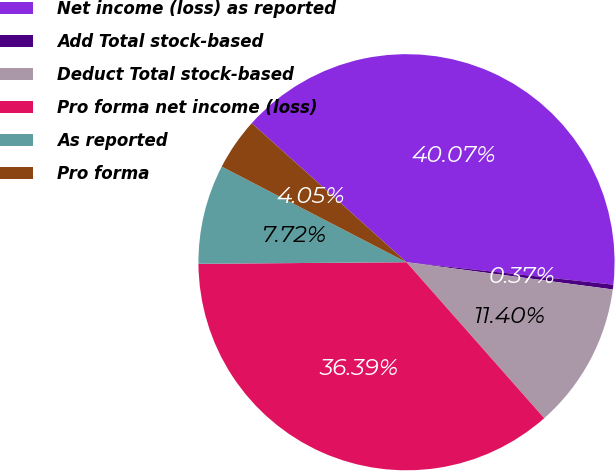Convert chart. <chart><loc_0><loc_0><loc_500><loc_500><pie_chart><fcel>Net income (loss) as reported<fcel>Add Total stock-based<fcel>Deduct Total stock-based<fcel>Pro forma net income (loss)<fcel>As reported<fcel>Pro forma<nl><fcel>40.07%<fcel>0.37%<fcel>11.4%<fcel>36.39%<fcel>7.72%<fcel>4.05%<nl></chart> 